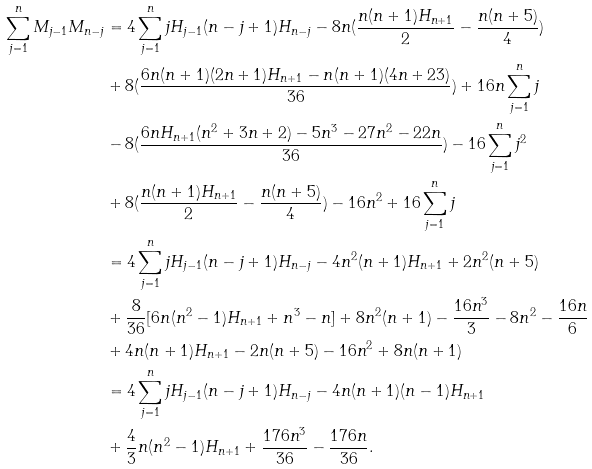<formula> <loc_0><loc_0><loc_500><loc_500>\sum _ { j = 1 } ^ { n } M _ { j - 1 } M _ { n - j } & = 4 \sum _ { j = 1 } ^ { n } j H _ { j - 1 } ( n - j + 1 ) H _ { n - j } - 8 n ( \frac { n ( n + 1 ) H _ { n + 1 } } { 2 } - \frac { n ( n + 5 ) } { 4 } ) \\ & + 8 ( \frac { 6 n ( n + 1 ) ( 2 n + 1 ) H _ { n + 1 } - n ( n + 1 ) ( 4 n + 2 3 ) } { 3 6 } ) + 1 6 n \sum _ { j = 1 } ^ { n } j \\ & - 8 ( \frac { 6 n H _ { n + 1 } ( n ^ { 2 } + 3 n + 2 ) - 5 n ^ { 3 } - 2 7 n ^ { 2 } - 2 2 n } { 3 6 } ) - 1 6 \sum _ { j = 1 } ^ { n } j ^ { 2 } \\ & + 8 ( \frac { n ( n + 1 ) H _ { n + 1 } } { 2 } - \frac { n ( n + 5 ) } { 4 } ) - 1 6 n ^ { 2 } + 1 6 \sum _ { j = 1 } ^ { n } j \\ & = 4 \sum _ { j = 1 } ^ { n } j H _ { j - 1 } ( n - j + 1 ) H _ { n - j } - 4 n ^ { 2 } ( n + 1 ) H _ { n + 1 } + 2 n ^ { 2 } ( n + 5 ) \\ & + \frac { 8 } { 3 6 } [ 6 n ( n ^ { 2 } - 1 ) H _ { n + 1 } + n ^ { 3 } - n ] + 8 n ^ { 2 } ( n + 1 ) - \frac { 1 6 n ^ { 3 } } { 3 } - 8 n ^ { 2 } - \frac { 1 6 n } { 6 } \\ & + 4 n ( n + 1 ) H _ { n + 1 } - 2 n ( n + 5 ) - 1 6 n ^ { 2 } + 8 n ( n + 1 ) \\ & = 4 \sum _ { j = 1 } ^ { n } j H _ { j - 1 } ( n - j + 1 ) H _ { n - j } - 4 n ( n + 1 ) ( n - 1 ) H _ { n + 1 } \\ & + \frac { 4 } { 3 } n ( n ^ { 2 } - 1 ) H _ { n + 1 } + \frac { 1 7 6 n ^ { 3 } } { 3 6 } - \frac { 1 7 6 n } { 3 6 } .</formula> 